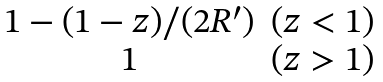<formula> <loc_0><loc_0><loc_500><loc_500>\begin{matrix} 1 - ( 1 - z ) / ( 2 R ^ { \prime } ) & ( z < 1 ) \\ 1 & ( z > 1 ) \end{matrix}</formula> 